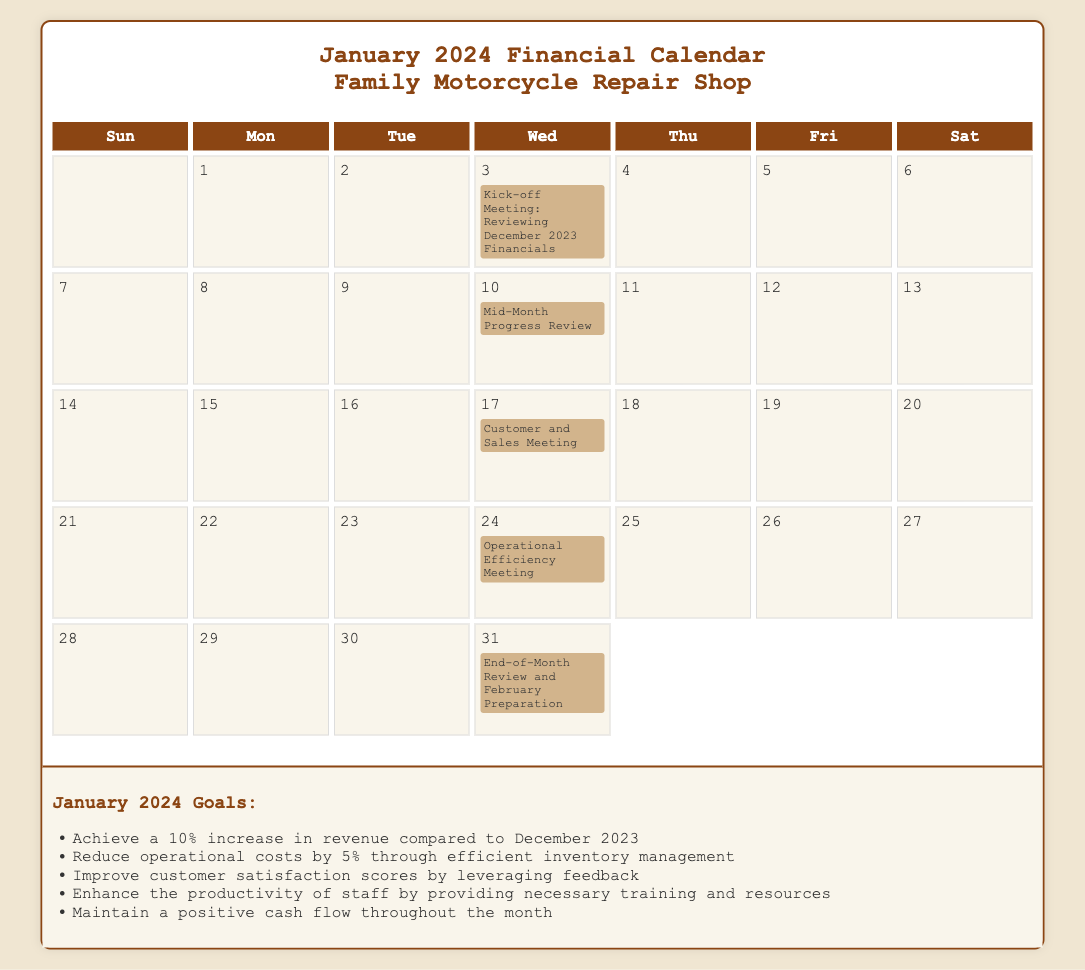What is the date of the Kick-off Meeting? The Kick-off Meeting is scheduled for January 3rd.
Answer: January 3rd What is the goal for revenue increase in January 2024? The goal is to achieve a 10% increase in revenue compared to December 2023.
Answer: 10% What meeting takes place on January 10th? The meeting on January 10th is called the Mid-Month Progress Review.
Answer: Mid-Month Progress Review Which event is scheduled for January 31st? The event scheduled for January 31st is the End-of-Month Review and February Preparation.
Answer: End-of-Month Review and February Preparation How many meetings are listed in the calendar? There are five meetings listed in the January 2024 calendar.
Answer: Five 